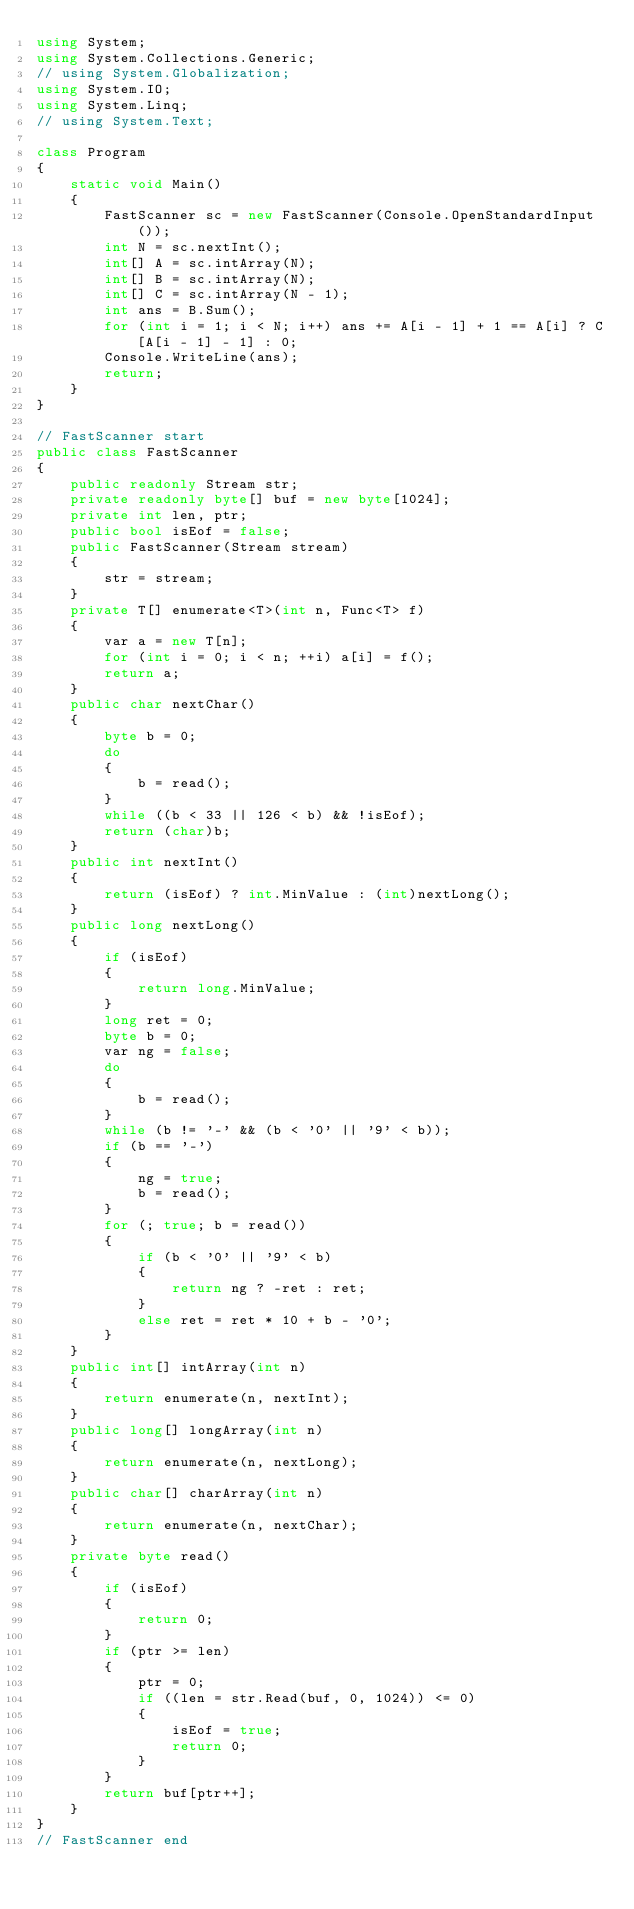Convert code to text. <code><loc_0><loc_0><loc_500><loc_500><_C#_>using System;
using System.Collections.Generic;
// using System.Globalization;
using System.IO;
using System.Linq;
// using System.Text;

class Program
{
    static void Main()
    {
        FastScanner sc = new FastScanner(Console.OpenStandardInput());
        int N = sc.nextInt();
        int[] A = sc.intArray(N);
        int[] B = sc.intArray(N);
        int[] C = sc.intArray(N - 1);
        int ans = B.Sum();
        for (int i = 1; i < N; i++) ans += A[i - 1] + 1 == A[i] ? C[A[i - 1] - 1] : 0;
        Console.WriteLine(ans);
        return;
    }
}

// FastScanner start
public class FastScanner
{
    public readonly Stream str;
    private readonly byte[] buf = new byte[1024];
    private int len, ptr;
    public bool isEof = false;
    public FastScanner(Stream stream)
    {
        str = stream;
    }
    private T[] enumerate<T>(int n, Func<T> f)
    {
        var a = new T[n];
        for (int i = 0; i < n; ++i) a[i] = f();
        return a;
    }
    public char nextChar()
    {
        byte b = 0;
        do
        {
            b = read();
        }
        while ((b < 33 || 126 < b) && !isEof);
        return (char)b;
    }
    public int nextInt()
    {
        return (isEof) ? int.MinValue : (int)nextLong();
    }
    public long nextLong()
    {
        if (isEof)
        {
            return long.MinValue;
        }
        long ret = 0;
        byte b = 0;
        var ng = false;
        do
        {
            b = read();
        }
        while (b != '-' && (b < '0' || '9' < b));
        if (b == '-')
        {
            ng = true;
            b = read();
        }
        for (; true; b = read())
        {
            if (b < '0' || '9' < b)
            {
                return ng ? -ret : ret;
            }
            else ret = ret * 10 + b - '0';
        }
    }
    public int[] intArray(int n)
    {
        return enumerate(n, nextInt);
    }
    public long[] longArray(int n)
    {
        return enumerate(n, nextLong);
    }
    public char[] charArray(int n)
    {
        return enumerate(n, nextChar);
    }
    private byte read()
    {
        if (isEof)
        {
            return 0;
        }
        if (ptr >= len)
        {
            ptr = 0;
            if ((len = str.Read(buf, 0, 1024)) <= 0)
            {
                isEof = true;
                return 0;
            }
        }
        return buf[ptr++];
    }
}
// FastScanner end</code> 